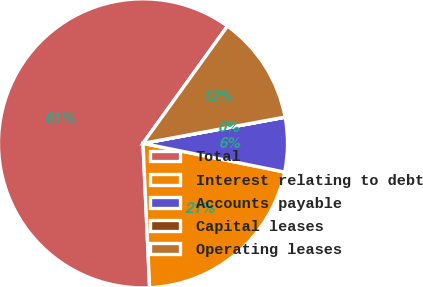Convert chart. <chart><loc_0><loc_0><loc_500><loc_500><pie_chart><fcel>Total<fcel>Interest relating to debt<fcel>Accounts payable<fcel>Capital leases<fcel>Operating leases<nl><fcel>60.67%<fcel>21.09%<fcel>6.08%<fcel>0.02%<fcel>12.15%<nl></chart> 